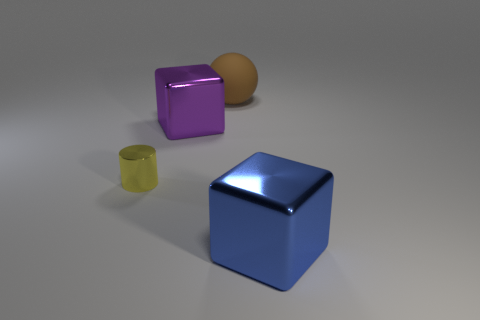Add 3 small purple cylinders. How many objects exist? 7 Subtract all spheres. How many objects are left? 3 Add 2 big green shiny spheres. How many big green shiny spheres exist? 2 Subtract 0 yellow spheres. How many objects are left? 4 Subtract all small cyan matte blocks. Subtract all cubes. How many objects are left? 2 Add 3 big purple metal blocks. How many big purple metal blocks are left? 4 